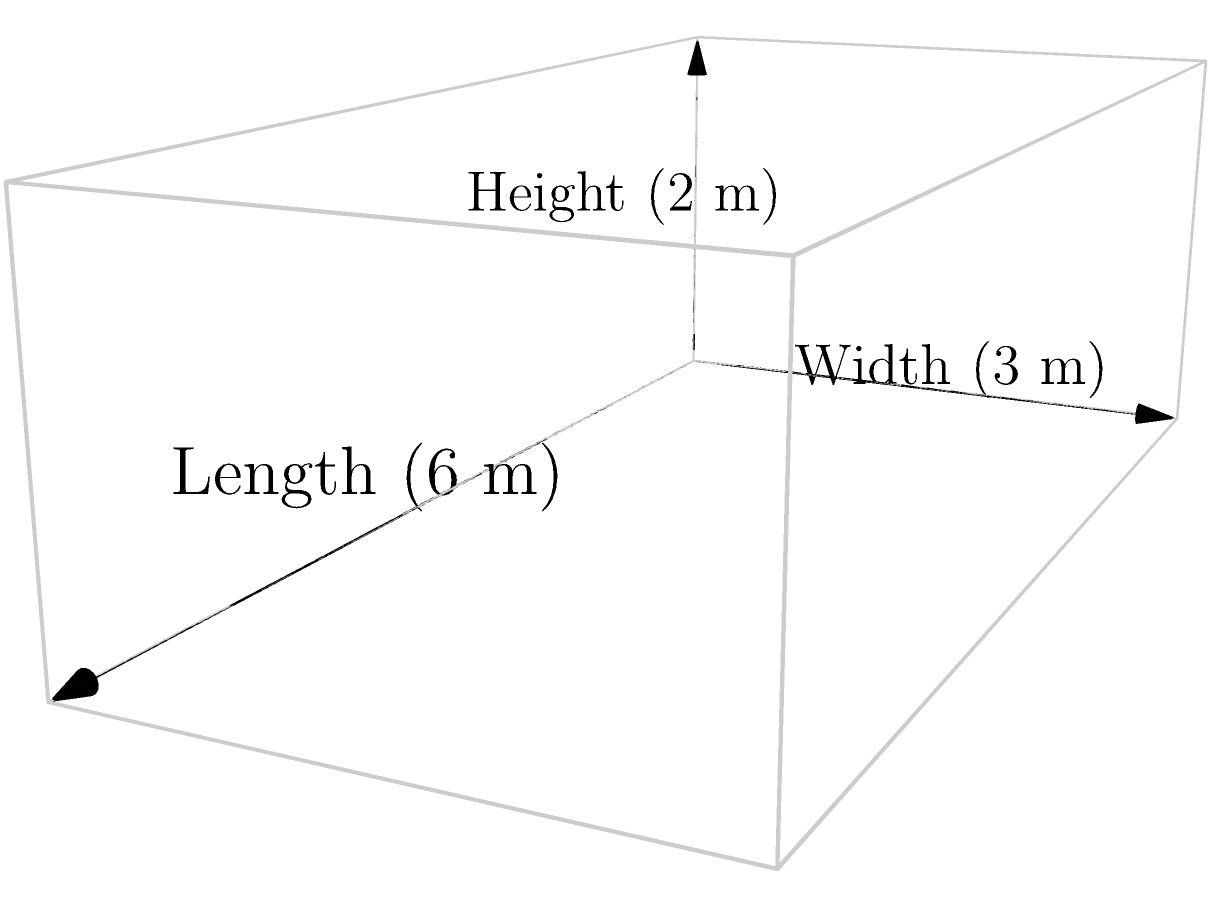As a restaurateur collaborating with food truck owners, you need to determine the interior volume of a rectangular food truck. Given that the food truck has a length of 6 meters, a width of 3 meters, and a height of 2 meters, calculate its volume in cubic meters. To calculate the volume of a rectangular prism (in this case, the food truck), we use the formula:

$$V = l \times w \times h$$

Where:
$V$ = Volume
$l$ = Length
$w$ = Width
$h$ = Height

Given:
Length ($l$) = 6 meters
Width ($w$) = 3 meters
Height ($h$) = 2 meters

Let's substitute these values into the formula:

$$V = 6 \text{ m} \times 3 \text{ m} \times 2 \text{ m}$$

Now, let's multiply:

$$V = 36 \text{ m}^3$$

Therefore, the volume of the food truck is 36 cubic meters.
Answer: $36 \text{ m}^3$ 